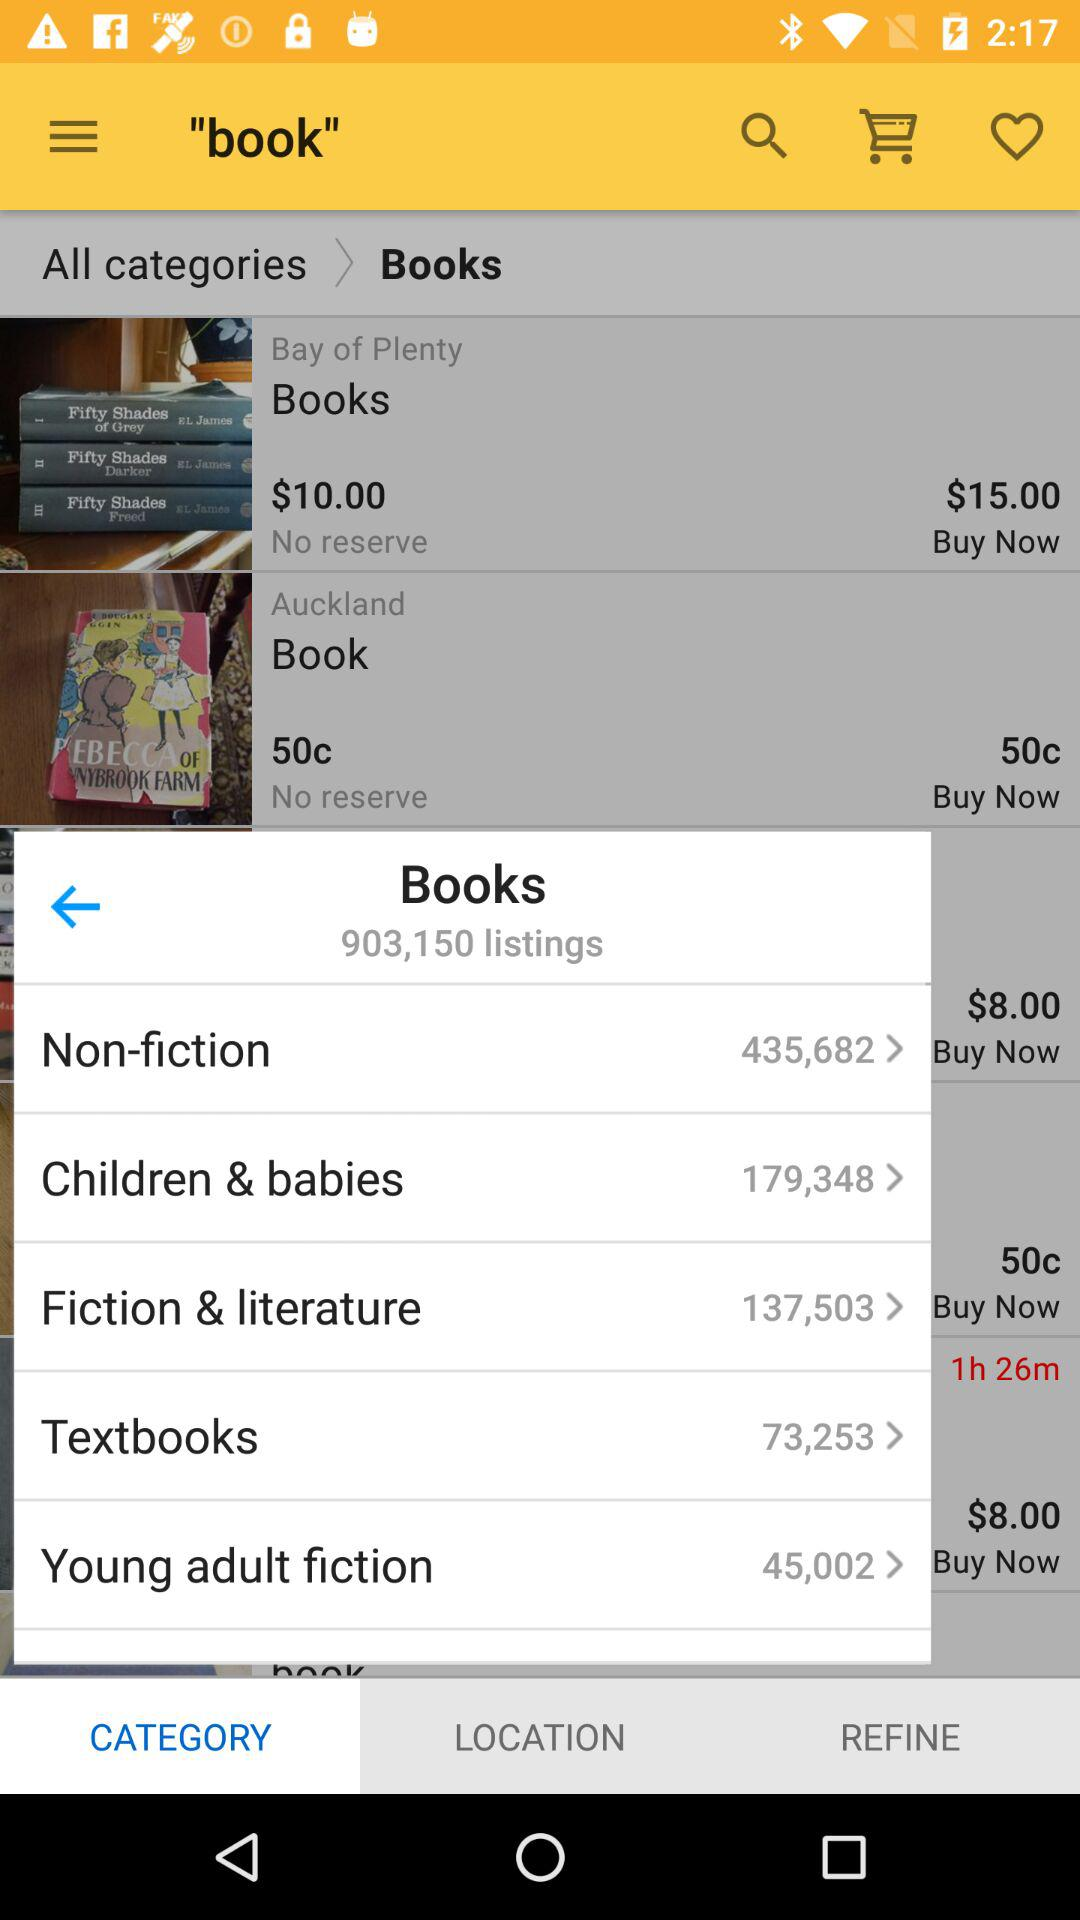How many non-fiction books are there? There are 435,682 non-fiction books. 